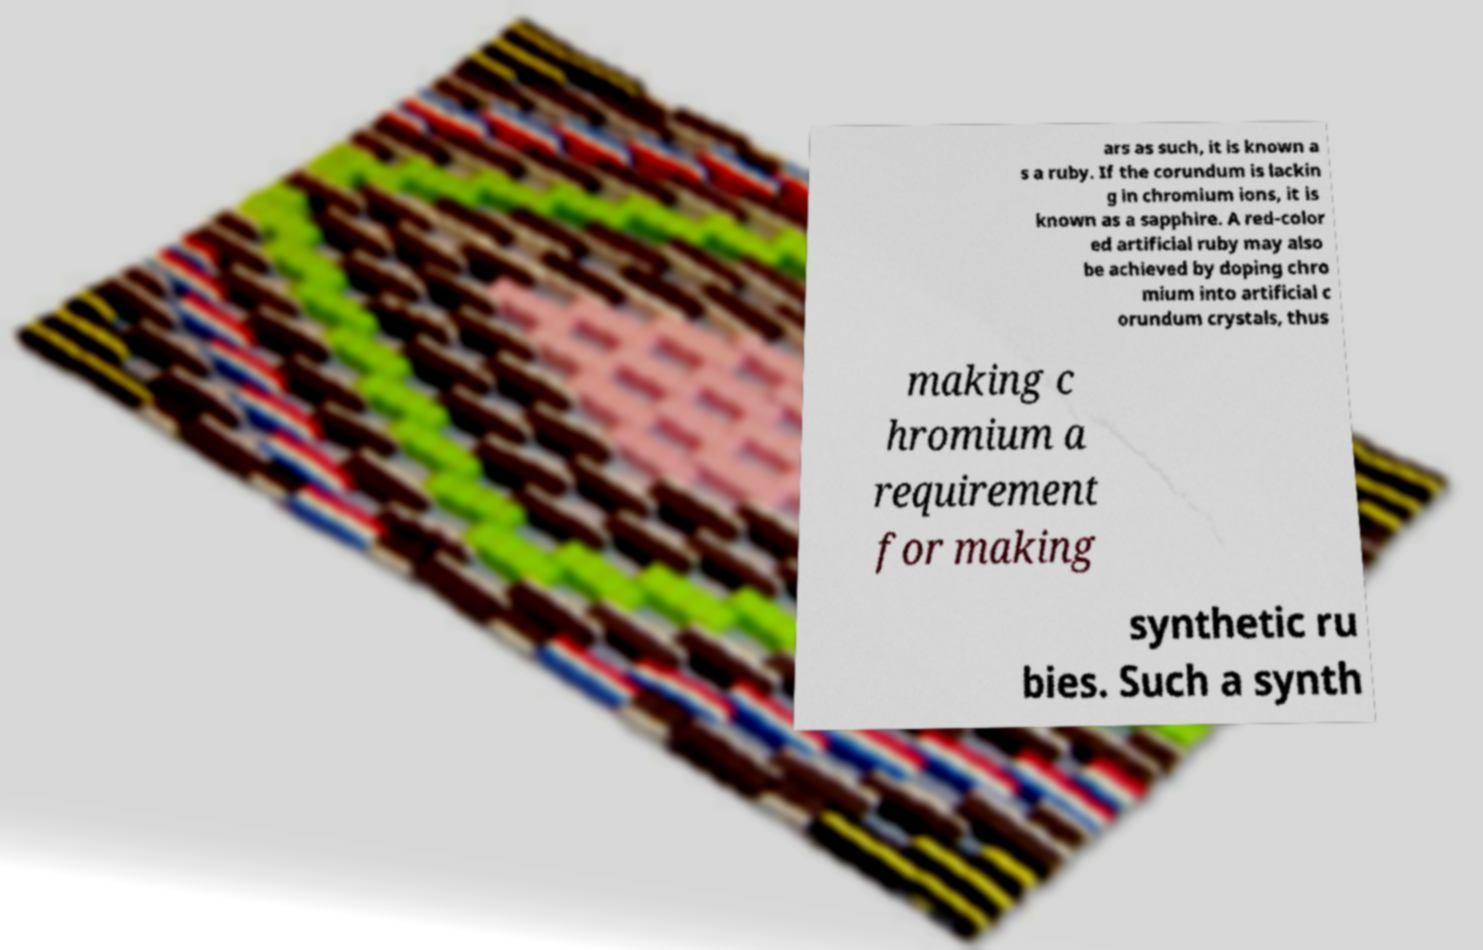For documentation purposes, I need the text within this image transcribed. Could you provide that? ars as such, it is known a s a ruby. If the corundum is lackin g in chromium ions, it is known as a sapphire. A red-color ed artificial ruby may also be achieved by doping chro mium into artificial c orundum crystals, thus making c hromium a requirement for making synthetic ru bies. Such a synth 